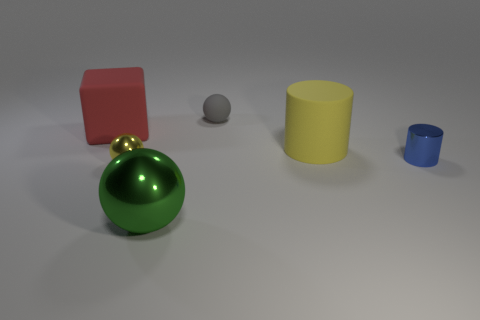There is a tiny yellow thing that is the same shape as the big green thing; what material is it?
Your response must be concise. Metal. Are there any tiny yellow objects behind the large green ball?
Your answer should be compact. Yes. What number of large red cylinders are there?
Make the answer very short. 0. What number of green metal spheres are to the right of the large matte object that is on the left side of the small rubber ball?
Make the answer very short. 1. Do the rubber cylinder and the tiny object that is in front of the metal cylinder have the same color?
Provide a succinct answer. Yes. How many other large red objects are the same shape as the big red thing?
Keep it short and to the point. 0. There is a large object that is in front of the shiny cylinder; what is it made of?
Make the answer very short. Metal. There is a matte object in front of the large red matte cube; is it the same shape as the tiny blue metal thing?
Give a very brief answer. Yes. Is there a cyan matte cylinder of the same size as the yellow cylinder?
Keep it short and to the point. No. There is a big shiny object; is its shape the same as the shiny object that is to the right of the yellow cylinder?
Your answer should be compact. No. 